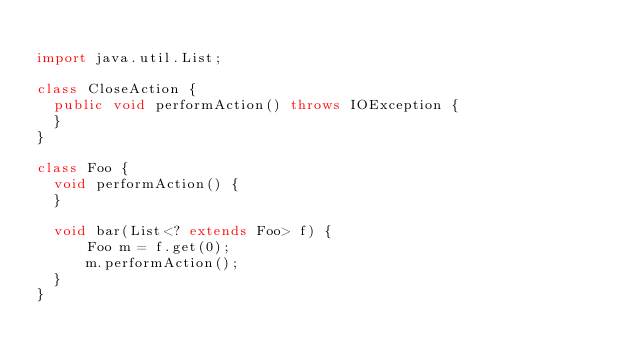<code> <loc_0><loc_0><loc_500><loc_500><_Java_>
import java.util.List;

class CloseAction {
  public void performAction() throws IOException {
  }
}

class Foo {
  void performAction() {
  }

  void bar(List<? extends Foo> f) {
      Foo m = f.get(0);
      m.performAction();
  }
}
</code> 